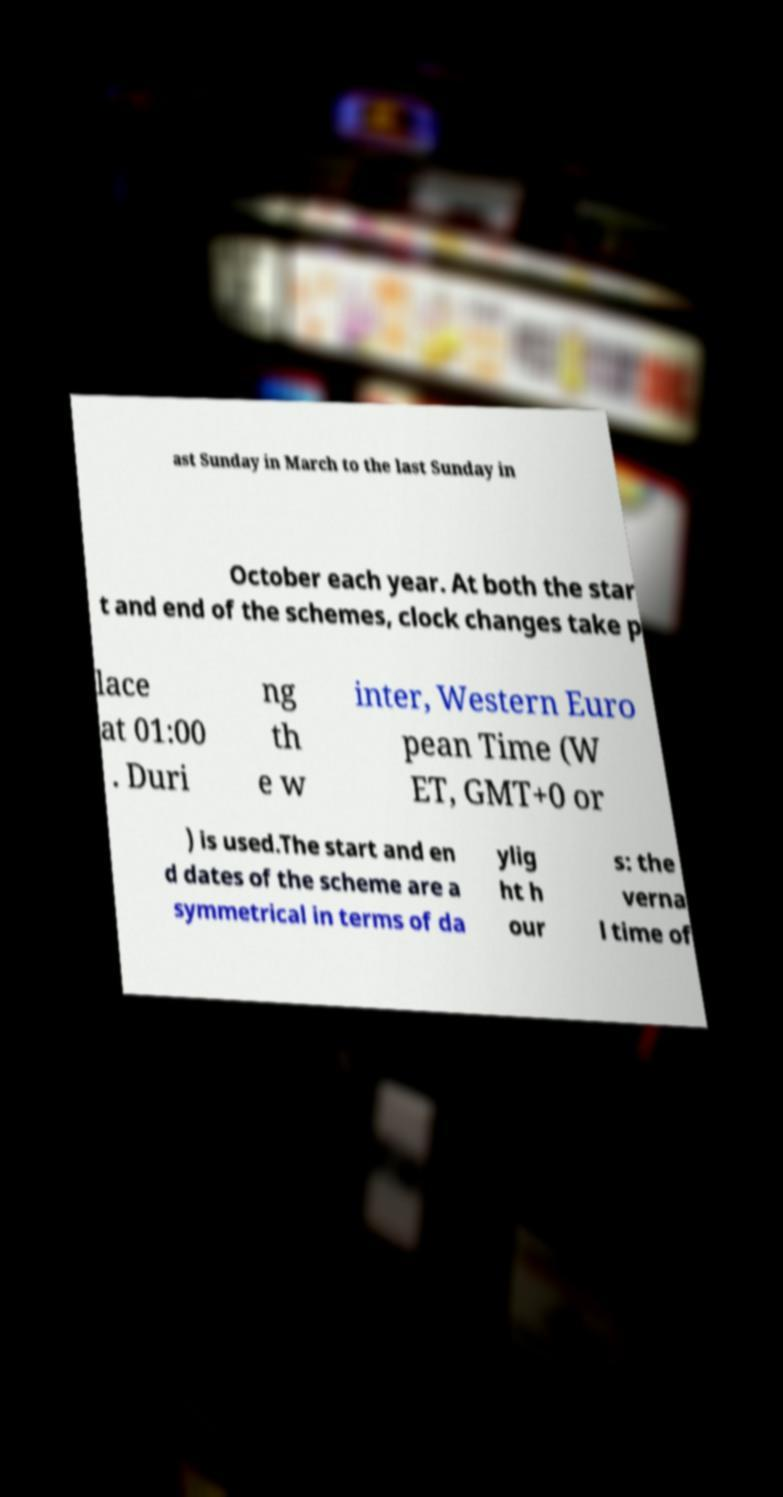I need the written content from this picture converted into text. Can you do that? ast Sunday in March to the last Sunday in October each year. At both the star t and end of the schemes, clock changes take p lace at 01:00 . Duri ng th e w inter, Western Euro pean Time (W ET, GMT+0 or ) is used.The start and en d dates of the scheme are a symmetrical in terms of da ylig ht h our s: the verna l time of 